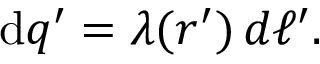<formula> <loc_0><loc_0><loc_500><loc_500>d q ^ { \prime } = \lambda ( { r ^ { \prime } } ) \, d \ell ^ { \prime } .</formula> 